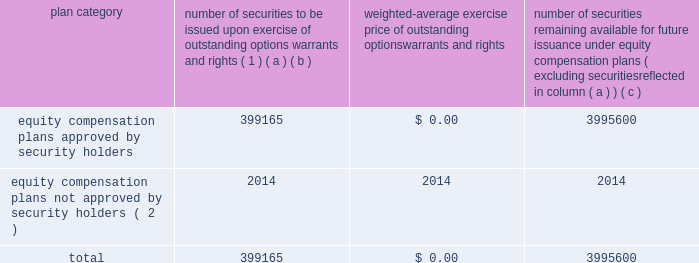Equity compensation plan information the table presents the equity securities available for issuance under our equity compensation plans as of december 31 , 2018 .
Equity compensation plan information plan category number of securities to be issued upon exercise of outstanding options , warrants and rights ( 1 ) weighted-average exercise price of outstanding options , warrants and rights number of securities remaining available for future issuance under equity compensation plans ( excluding securities reflected in column ( a ) ) ( a ) ( b ) ( c ) equity compensation plans approved by security holders 399165 $ 0.00 3995600 equity compensation plans not approved by security holders ( 2 ) 2014 2014 2014 .
( 1 ) includes grants made under the huntington ingalls industries , inc .
2012 long-term incentive stock plan ( the "2012 plan" ) , which was approved by our stockholders on may 2 , 2012 , and the huntington ingalls industries , inc .
2011 long-term incentive stock plan ( the "2011 plan" ) , which was approved by the sole stockholder of hii prior to its spin-off from northrop grumman corporation .
Of these shares , 27123 were stock rights granted under the 2011 plan .
In addition , this number includes 31697 stock rights , 5051 restricted stock rights , and 335293 restricted performance stock rights granted under the 2012 plan , assuming target performance achievement .
( 2 ) there are no awards made under plans not approved by security holders .
Item 13 .
Certain relationships and related transactions , and director independence information as to certain relationships and related transactions and director independence will be incorporated herein by reference to the proxy statement for our 2019 annual meeting of stockholders , to be filed within 120 days after the end of the company 2019s fiscal year .
Item 14 .
Principal accountant fees and services information as to principal accountant fees and services will be incorporated herein by reference to the proxy statement for our 2019 annual meeting of stockholders , to be filed within 120 days after the end of the company 2019s fiscal year. .
As of december 312018 what was the ratio of the equity compensation plans approved by security holders number of securities to be issued to the number of securities remaining available for future issuance? 
Rationale: for every security remaining available for future issuance there is 0.1 securities issued
Computations: (399165 / 3995600)
Answer: 0.0999. 